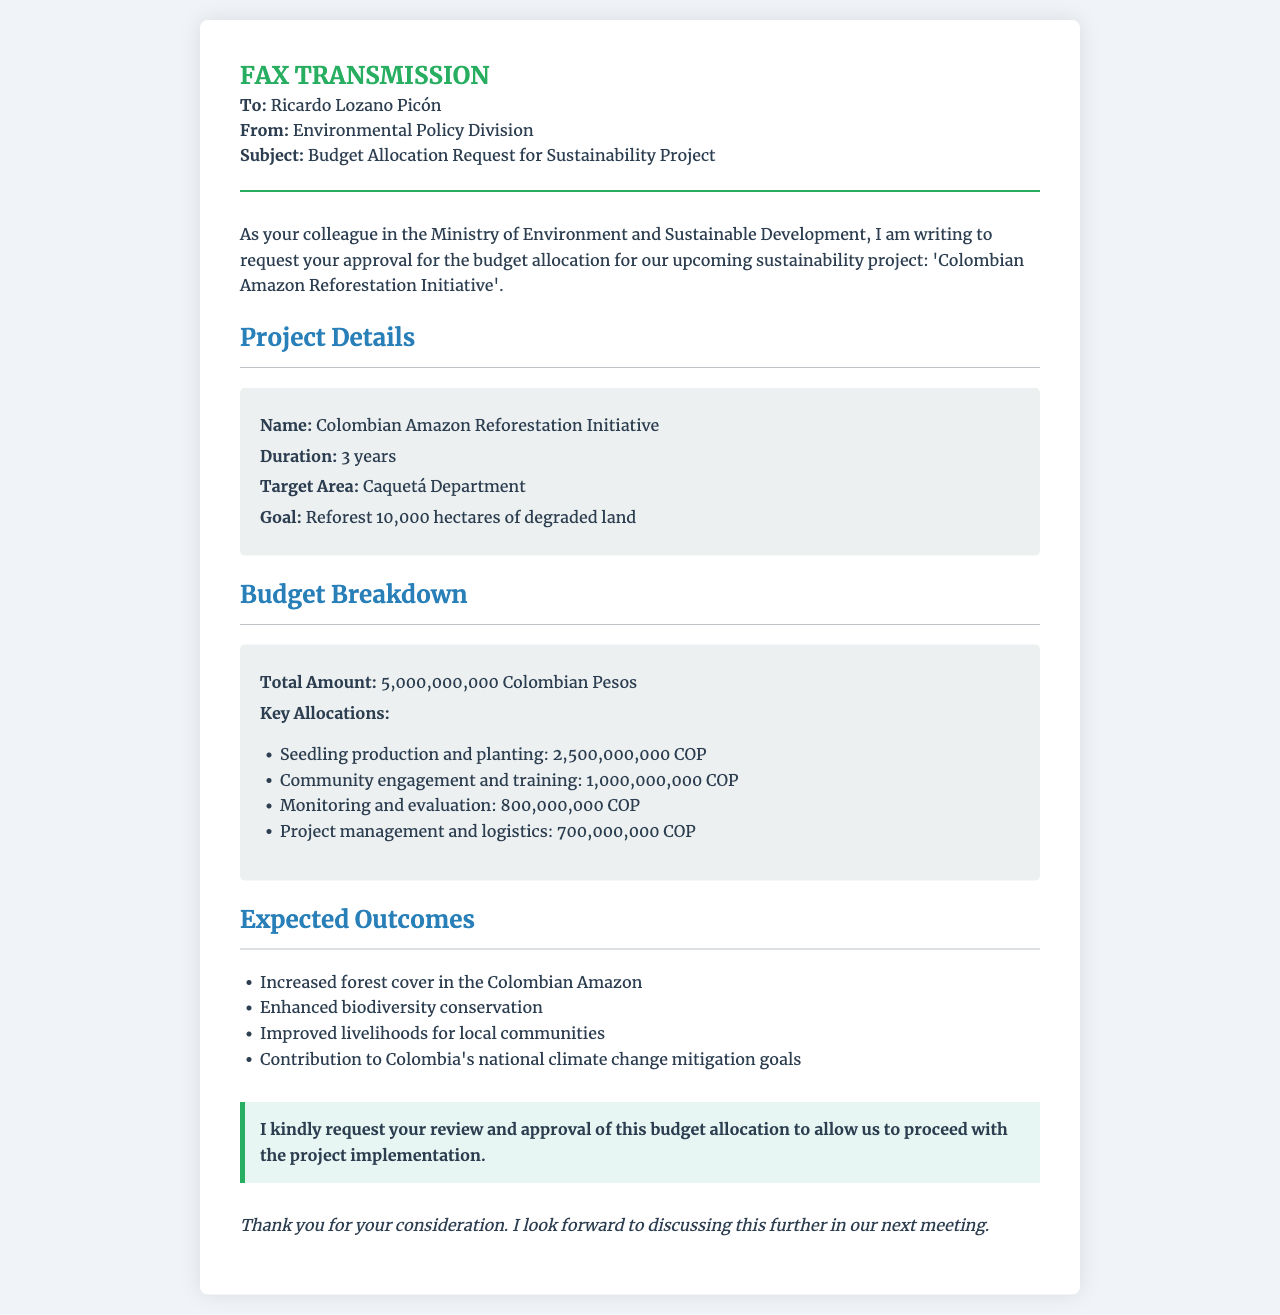What is the name of the project? The project name is explicitly mentioned in the document, which is the "Colombian Amazon Reforestation Initiative."
Answer: Colombian Amazon Reforestation Initiative What is the total budget amount? The total budget amount is clearly stated in the budget breakdown section of the document.
Answer: 5,000,000,000 Colombian Pesos What is the duration of the project? The duration of the project is specified as part of the project details in the document.
Answer: 3 years What is the target area for the project? The target area is provided in the project details section of the fax, indicating where the project will focus efforts.
Answer: Caquetá Department How many hectares does the project aim to reforest? The goal for reforestation is outlined in the project details section, indicating the extent of land to be reforested.
Answer: 10,000 hectares What allocation is earmarked for seedling production and planting? The budget breakdown lists amounts allocated for specific activities, including seedling production and planting.
Answer: 2,500,000,000 COP What is one expected outcome of the project related to biodiversity? The document lists expected outcomes of the project, including aspects related to biodiversity conservation.
Answer: Enhanced biodiversity conservation What is the purpose of this fax? The main intention of the fax is to request approval from Ricardo Lozano Picón for the budget allocation.
Answer: Budget allocation request What role does the Environmental Policy Division play in this document? The Environmental Policy Division is the sender of the fax, indicating their authority in the context of this request.
Answer: Sender of the fax 